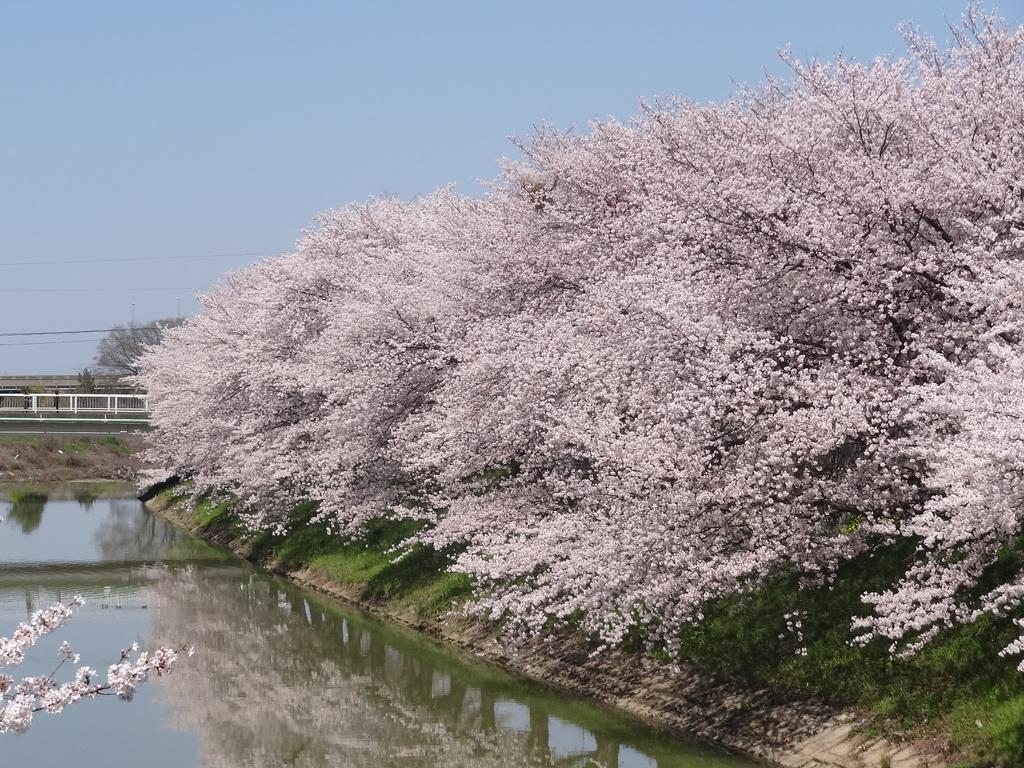What type of trees are present in the image? There are trees with pink color flowers in the image. What else can be seen in the image besides the trees? There is water visible in the image. What is visible in the background of the image? The sky is visible in the background of the image. What is the tendency of the middle side of the image? There is no concept of a "middle side" in the image, as it is a two-dimensional representation. 